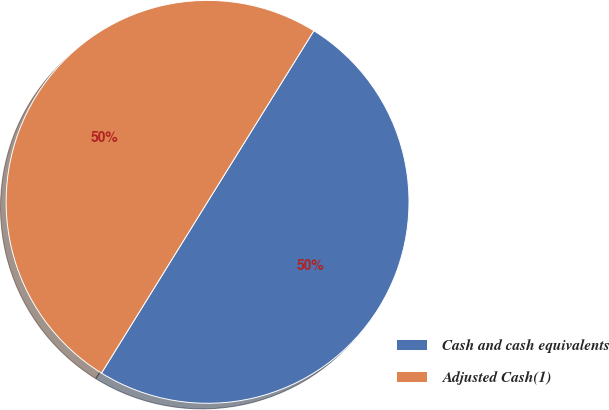Convert chart. <chart><loc_0><loc_0><loc_500><loc_500><pie_chart><fcel>Cash and cash equivalents<fcel>Adjusted Cash(1)<nl><fcel>49.98%<fcel>50.02%<nl></chart> 